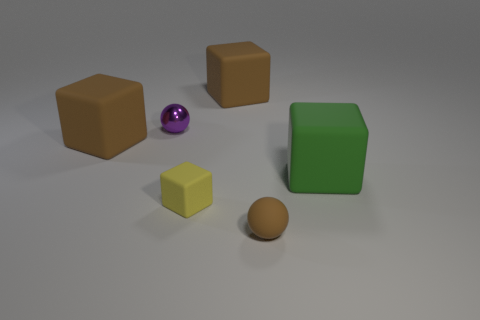Add 1 big purple spheres. How many objects exist? 7 Add 5 large shiny cylinders. How many large shiny cylinders exist? 5 Subtract all purple spheres. How many spheres are left? 1 Subtract all big rubber blocks. How many blocks are left? 1 Subtract 0 green balls. How many objects are left? 6 Subtract all balls. How many objects are left? 4 Subtract 2 blocks. How many blocks are left? 2 Subtract all green spheres. Subtract all brown cylinders. How many spheres are left? 2 Subtract all gray balls. How many brown cubes are left? 2 Subtract all big metallic balls. Subtract all tiny spheres. How many objects are left? 4 